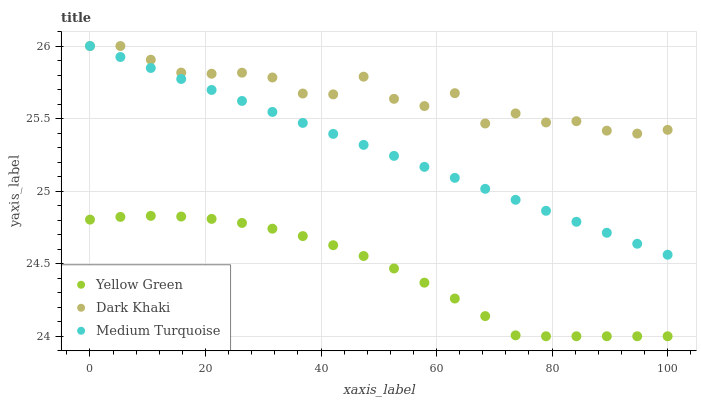Does Yellow Green have the minimum area under the curve?
Answer yes or no. Yes. Does Dark Khaki have the maximum area under the curve?
Answer yes or no. Yes. Does Medium Turquoise have the minimum area under the curve?
Answer yes or no. No. Does Medium Turquoise have the maximum area under the curve?
Answer yes or no. No. Is Medium Turquoise the smoothest?
Answer yes or no. Yes. Is Dark Khaki the roughest?
Answer yes or no. Yes. Is Yellow Green the smoothest?
Answer yes or no. No. Is Yellow Green the roughest?
Answer yes or no. No. Does Yellow Green have the lowest value?
Answer yes or no. Yes. Does Medium Turquoise have the lowest value?
Answer yes or no. No. Does Medium Turquoise have the highest value?
Answer yes or no. Yes. Does Yellow Green have the highest value?
Answer yes or no. No. Is Yellow Green less than Medium Turquoise?
Answer yes or no. Yes. Is Medium Turquoise greater than Yellow Green?
Answer yes or no. Yes. Does Dark Khaki intersect Medium Turquoise?
Answer yes or no. Yes. Is Dark Khaki less than Medium Turquoise?
Answer yes or no. No. Is Dark Khaki greater than Medium Turquoise?
Answer yes or no. No. Does Yellow Green intersect Medium Turquoise?
Answer yes or no. No. 